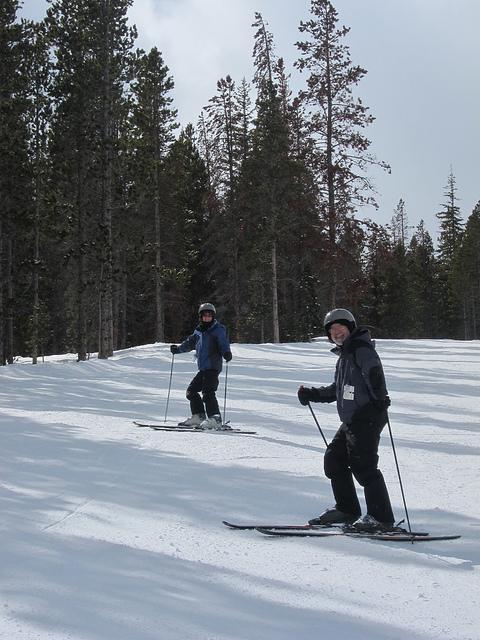How many skiers are there?
Give a very brief answer. 2. How many people are there?
Give a very brief answer. 2. 